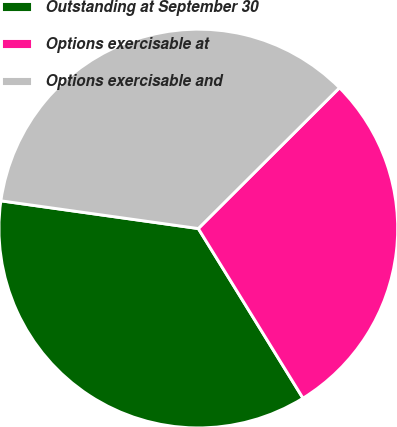<chart> <loc_0><loc_0><loc_500><loc_500><pie_chart><fcel>Outstanding at September 30<fcel>Options exercisable at<fcel>Options exercisable and<nl><fcel>36.02%<fcel>28.68%<fcel>35.3%<nl></chart> 